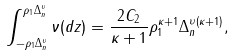<formula> <loc_0><loc_0><loc_500><loc_500>\int _ { - \rho _ { 1 } \Delta _ { n } ^ { \upsilon } } ^ { \rho _ { 1 } \Delta _ { n } ^ { \upsilon } } \nu ( d z ) = \frac { 2 C _ { 2 } } { \kappa + 1 } \rho _ { 1 } ^ { \kappa + 1 } \Delta _ { n } ^ { \upsilon \left ( \kappa + 1 \right ) } ,</formula> 